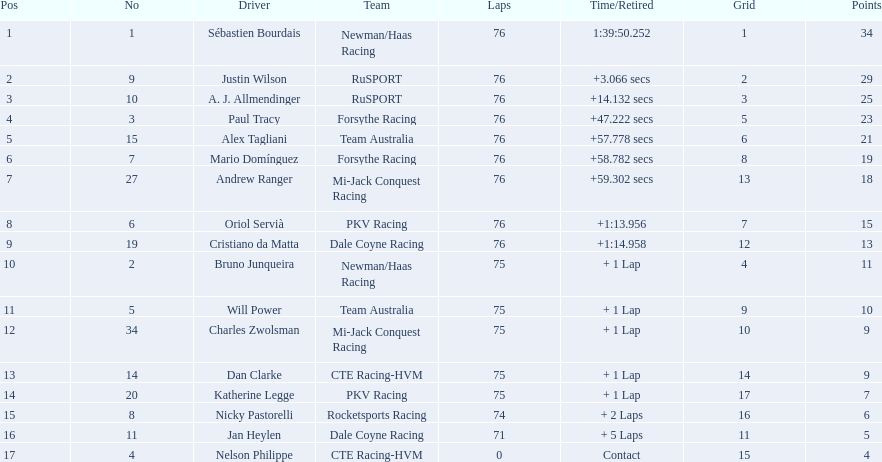Who drove during the 2006 tecate grand prix of monterrey? Sébastien Bourdais, Justin Wilson, A. J. Allmendinger, Paul Tracy, Alex Tagliani, Mario Domínguez, Andrew Ranger, Oriol Servià, Cristiano da Matta, Bruno Junqueira, Will Power, Charles Zwolsman, Dan Clarke, Katherine Legge, Nicky Pastorelli, Jan Heylen, Nelson Philippe. And what were their finishing positions? 1, 2, 3, 4, 5, 6, 7, 8, 9, 10, 11, 12, 13, 14, 15, 16, 17. Who did alex tagliani finish directly behind of? Paul Tracy. 